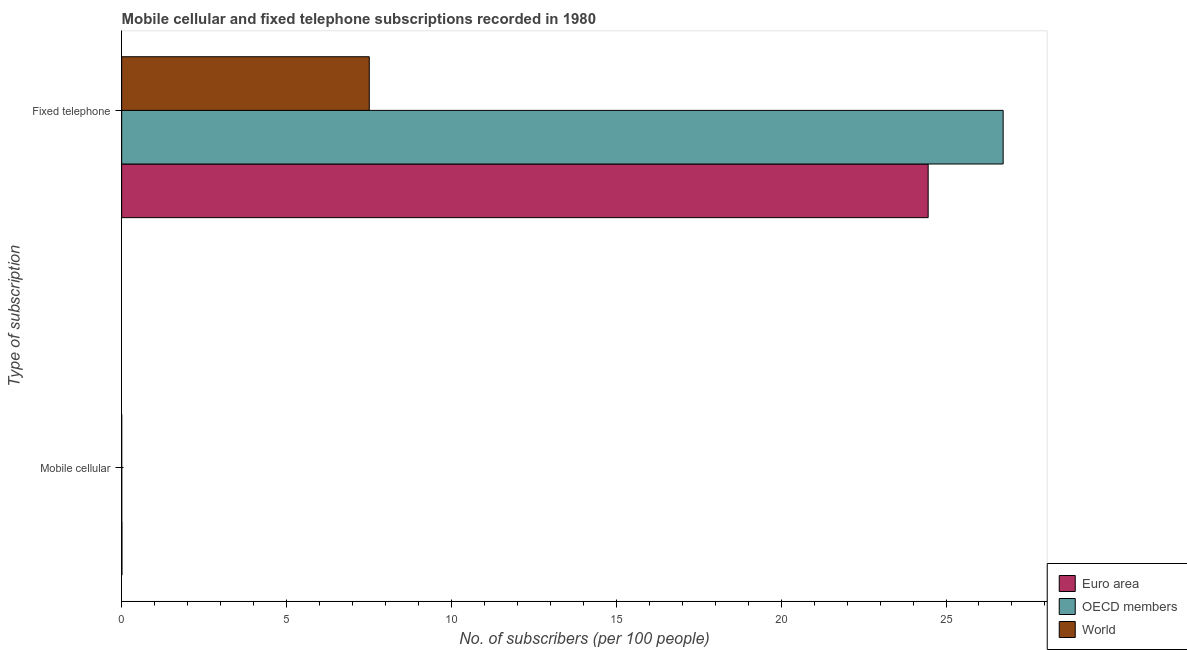What is the label of the 1st group of bars from the top?
Offer a very short reply. Fixed telephone. What is the number of mobile cellular subscribers in OECD members?
Offer a very short reply. 0. Across all countries, what is the maximum number of mobile cellular subscribers?
Provide a short and direct response. 0.01. Across all countries, what is the minimum number of mobile cellular subscribers?
Provide a short and direct response. 0. In which country was the number of mobile cellular subscribers maximum?
Offer a very short reply. Euro area. What is the total number of fixed telephone subscribers in the graph?
Provide a short and direct response. 58.7. What is the difference between the number of mobile cellular subscribers in Euro area and that in OECD members?
Make the answer very short. 0.01. What is the difference between the number of mobile cellular subscribers in Euro area and the number of fixed telephone subscribers in OECD members?
Provide a short and direct response. -26.73. What is the average number of fixed telephone subscribers per country?
Ensure brevity in your answer.  19.57. What is the difference between the number of mobile cellular subscribers and number of fixed telephone subscribers in OECD members?
Offer a very short reply. -26.73. What is the ratio of the number of mobile cellular subscribers in World to that in Euro area?
Ensure brevity in your answer.  0.07. Is the number of fixed telephone subscribers in OECD members less than that in World?
Offer a terse response. No. What does the 1st bar from the bottom in Fixed telephone represents?
Offer a terse response. Euro area. Are all the bars in the graph horizontal?
Your answer should be very brief. Yes. How many countries are there in the graph?
Give a very brief answer. 3. Are the values on the major ticks of X-axis written in scientific E-notation?
Your answer should be very brief. No. Does the graph contain grids?
Ensure brevity in your answer.  No. How are the legend labels stacked?
Provide a succinct answer. Vertical. What is the title of the graph?
Offer a terse response. Mobile cellular and fixed telephone subscriptions recorded in 1980. What is the label or title of the X-axis?
Your answer should be compact. No. of subscribers (per 100 people). What is the label or title of the Y-axis?
Keep it short and to the point. Type of subscription. What is the No. of subscribers (per 100 people) in Euro area in Mobile cellular?
Offer a terse response. 0.01. What is the No. of subscribers (per 100 people) in OECD members in Mobile cellular?
Provide a succinct answer. 0. What is the No. of subscribers (per 100 people) in World in Mobile cellular?
Keep it short and to the point. 0. What is the No. of subscribers (per 100 people) in Euro area in Fixed telephone?
Make the answer very short. 24.46. What is the No. of subscribers (per 100 people) of OECD members in Fixed telephone?
Keep it short and to the point. 26.73. What is the No. of subscribers (per 100 people) in World in Fixed telephone?
Make the answer very short. 7.51. Across all Type of subscription, what is the maximum No. of subscribers (per 100 people) in Euro area?
Ensure brevity in your answer.  24.46. Across all Type of subscription, what is the maximum No. of subscribers (per 100 people) in OECD members?
Provide a short and direct response. 26.73. Across all Type of subscription, what is the maximum No. of subscribers (per 100 people) of World?
Your answer should be very brief. 7.51. Across all Type of subscription, what is the minimum No. of subscribers (per 100 people) in Euro area?
Your answer should be compact. 0.01. Across all Type of subscription, what is the minimum No. of subscribers (per 100 people) of OECD members?
Keep it short and to the point. 0. Across all Type of subscription, what is the minimum No. of subscribers (per 100 people) in World?
Your answer should be compact. 0. What is the total No. of subscribers (per 100 people) of Euro area in the graph?
Offer a terse response. 24.47. What is the total No. of subscribers (per 100 people) of OECD members in the graph?
Your answer should be very brief. 26.74. What is the total No. of subscribers (per 100 people) of World in the graph?
Provide a succinct answer. 7.51. What is the difference between the No. of subscribers (per 100 people) in Euro area in Mobile cellular and that in Fixed telephone?
Ensure brevity in your answer.  -24.45. What is the difference between the No. of subscribers (per 100 people) of OECD members in Mobile cellular and that in Fixed telephone?
Ensure brevity in your answer.  -26.73. What is the difference between the No. of subscribers (per 100 people) of World in Mobile cellular and that in Fixed telephone?
Offer a very short reply. -7.51. What is the difference between the No. of subscribers (per 100 people) of Euro area in Mobile cellular and the No. of subscribers (per 100 people) of OECD members in Fixed telephone?
Your answer should be compact. -26.73. What is the difference between the No. of subscribers (per 100 people) of Euro area in Mobile cellular and the No. of subscribers (per 100 people) of World in Fixed telephone?
Offer a very short reply. -7.5. What is the difference between the No. of subscribers (per 100 people) in OECD members in Mobile cellular and the No. of subscribers (per 100 people) in World in Fixed telephone?
Keep it short and to the point. -7.51. What is the average No. of subscribers (per 100 people) in Euro area per Type of subscription?
Your answer should be very brief. 12.23. What is the average No. of subscribers (per 100 people) in OECD members per Type of subscription?
Your answer should be very brief. 13.37. What is the average No. of subscribers (per 100 people) of World per Type of subscription?
Your response must be concise. 3.75. What is the difference between the No. of subscribers (per 100 people) of Euro area and No. of subscribers (per 100 people) of OECD members in Mobile cellular?
Offer a very short reply. 0.01. What is the difference between the No. of subscribers (per 100 people) of Euro area and No. of subscribers (per 100 people) of World in Mobile cellular?
Offer a terse response. 0.01. What is the difference between the No. of subscribers (per 100 people) of OECD members and No. of subscribers (per 100 people) of World in Mobile cellular?
Keep it short and to the point. 0. What is the difference between the No. of subscribers (per 100 people) of Euro area and No. of subscribers (per 100 people) of OECD members in Fixed telephone?
Offer a very short reply. -2.27. What is the difference between the No. of subscribers (per 100 people) in Euro area and No. of subscribers (per 100 people) in World in Fixed telephone?
Offer a terse response. 16.95. What is the difference between the No. of subscribers (per 100 people) of OECD members and No. of subscribers (per 100 people) of World in Fixed telephone?
Your response must be concise. 19.22. What is the ratio of the No. of subscribers (per 100 people) of OECD members in Mobile cellular to that in Fixed telephone?
Offer a terse response. 0. What is the ratio of the No. of subscribers (per 100 people) of World in Mobile cellular to that in Fixed telephone?
Keep it short and to the point. 0. What is the difference between the highest and the second highest No. of subscribers (per 100 people) in Euro area?
Your response must be concise. 24.45. What is the difference between the highest and the second highest No. of subscribers (per 100 people) of OECD members?
Your answer should be compact. 26.73. What is the difference between the highest and the second highest No. of subscribers (per 100 people) in World?
Offer a terse response. 7.51. What is the difference between the highest and the lowest No. of subscribers (per 100 people) in Euro area?
Offer a very short reply. 24.45. What is the difference between the highest and the lowest No. of subscribers (per 100 people) of OECD members?
Your response must be concise. 26.73. What is the difference between the highest and the lowest No. of subscribers (per 100 people) of World?
Provide a succinct answer. 7.51. 